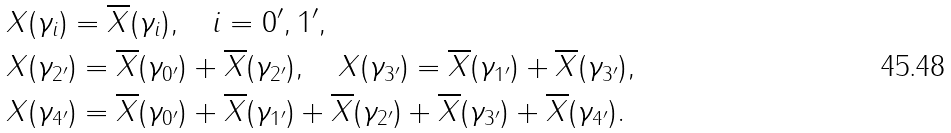Convert formula to latex. <formula><loc_0><loc_0><loc_500><loc_500>& X ( \gamma _ { i } ) = \overline { X } ( \gamma _ { i } ) , \quad i = 0 ^ { \prime } , 1 ^ { \prime } , \\ & X ( \gamma _ { 2 ^ { \prime } } ) = \overline { X } ( \gamma _ { 0 ^ { \prime } } ) + \overline { X } ( \gamma _ { 2 ^ { \prime } } ) , \quad X ( \gamma _ { 3 ^ { \prime } } ) = \overline { X } ( \gamma _ { 1 ^ { \prime } } ) + \overline { X } ( \gamma _ { 3 ^ { \prime } } ) , \\ & X ( \gamma _ { 4 ^ { \prime } } ) = \overline { X } ( \gamma _ { 0 ^ { \prime } } ) + \overline { X } ( \gamma _ { 1 ^ { \prime } } ) + \overline { X } ( \gamma _ { 2 ^ { \prime } } ) + \overline { X } ( \gamma _ { 3 ^ { \prime } } ) + \overline { X } ( \gamma _ { 4 ^ { \prime } } ) .</formula> 